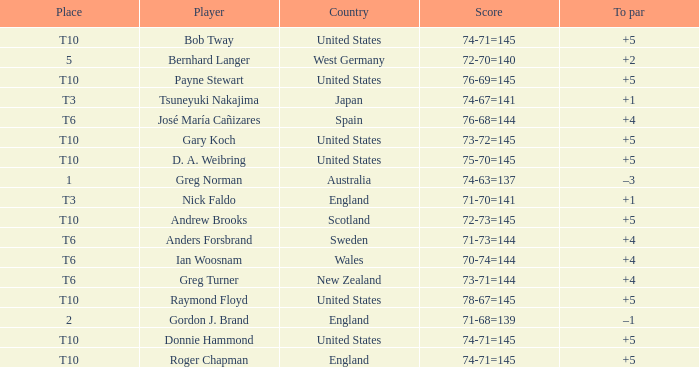What did United States place when the player was Raymond Floyd? T10. 